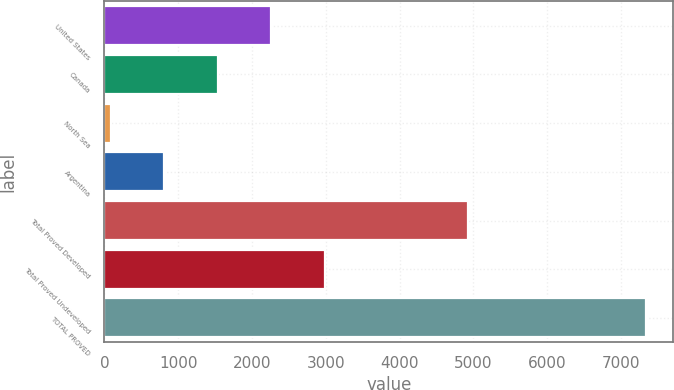Convert chart. <chart><loc_0><loc_0><loc_500><loc_500><bar_chart><fcel>United States<fcel>Canada<fcel>North Sea<fcel>Argentina<fcel>Total Proved Developed<fcel>Total Proved Undeveloped<fcel>TOTAL PROVED<nl><fcel>2263<fcel>1538<fcel>88<fcel>813<fcel>4926<fcel>2988<fcel>7338<nl></chart> 